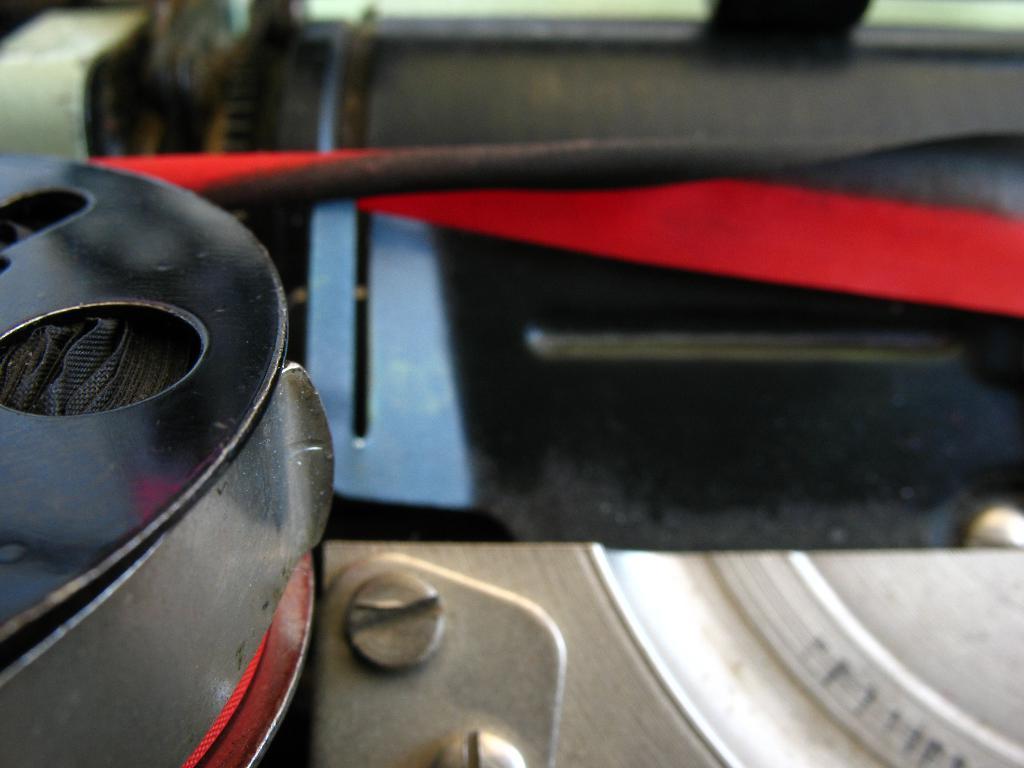Could you give a brief overview of what you see in this image? In this image I can see the zoomed-in picture in which I can see few objects which are blue, black, red , grey and white in color. 